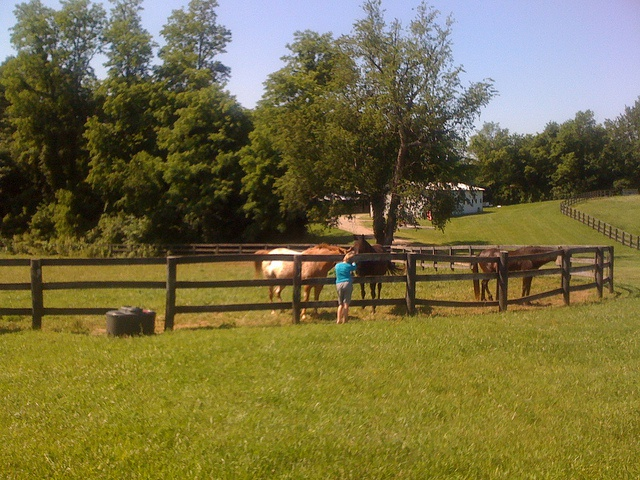Describe the objects in this image and their specific colors. I can see horse in lavender, maroon, tan, brown, and ivory tones, horse in lavender, maroon, black, and gray tones, horse in lavender, black, maroon, and olive tones, and people in lavender, maroon, blue, and gray tones in this image. 